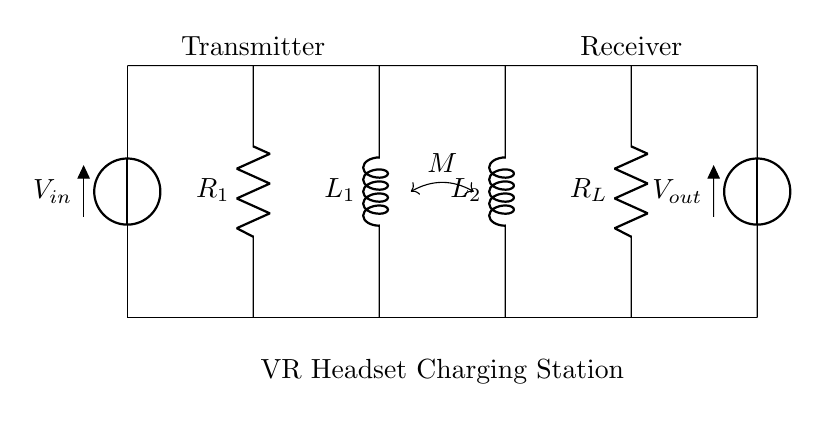What are the two types of components shown in this circuit? The components in this circuit consist of resistors and inductors, as indicated by the letters R and L.
Answer: resistors and inductors What is the role of mutual inductance in this circuit? Mutual inductance (denoted as M) allows energy transfer between the transmitter and receiver coils (L1 and L2) without a direct electrical connection, facilitating wireless power transfer.
Answer: energy transfer What is the input voltage of the circuit? The input voltage, labeled as V_in, is the potential difference supplied to the circuit, but it's not quantified in the diagram.
Answer: unspecified What component connects to the longest vertical line in the transmitter section? The longest vertical line in the transmitter section connects to V_in, which indicates that it supplies power to the circuit.
Answer: V_in How are the transmitter and receiver sections linked? The transmitter and receiver sections are linked by mutual inductance (M) which is represented by the line with a double arrow between the inductors L1 and L2.
Answer: mutual inductance What does R_L represent? R_L represents the load resistor in the receiver section, which absorbs the power transferred to the VR headset.
Answer: load resistor How many inductors are present in this circuit? There are two inductors shown in the circuit: L1 in the transmitter and L2 in the receiver.
Answer: two inductors 